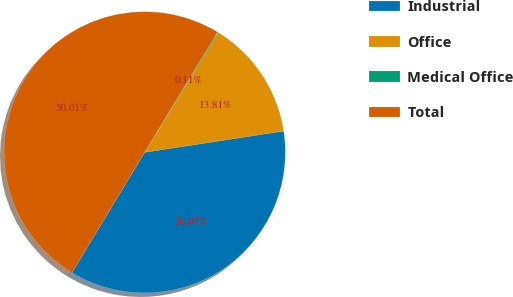Convert chart. <chart><loc_0><loc_0><loc_500><loc_500><pie_chart><fcel>Industrial<fcel>Office<fcel>Medical Office<fcel>Total<nl><fcel>36.07%<fcel>13.81%<fcel>0.11%<fcel>50.01%<nl></chart> 